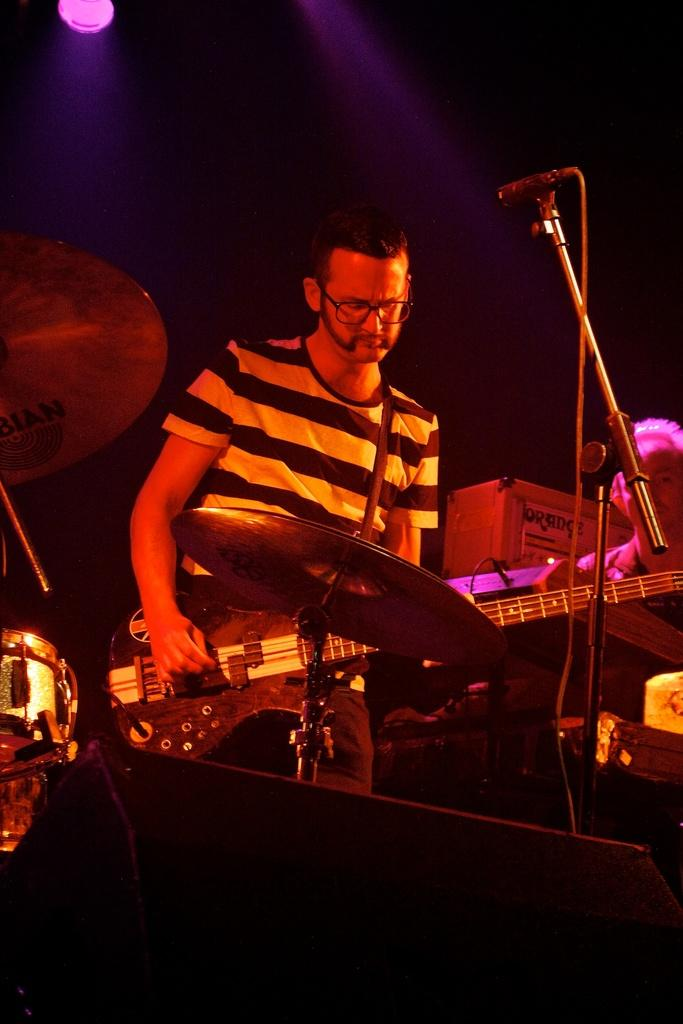What is the man in the image holding? The man is holding a guitar. What is in front of the man that is related to singing or speaking? There is a microphone with a stand in front of the man. What other musical instruments can be seen in the image? There are music instruments in the image. What color is the background behind the man? The background of the man is white. What can be seen in the background that provides illumination? There is a light in the background. What type of goose is sitting on the man's elbow in the image? There is no goose present in the image, and the man's elbow is not visible. 